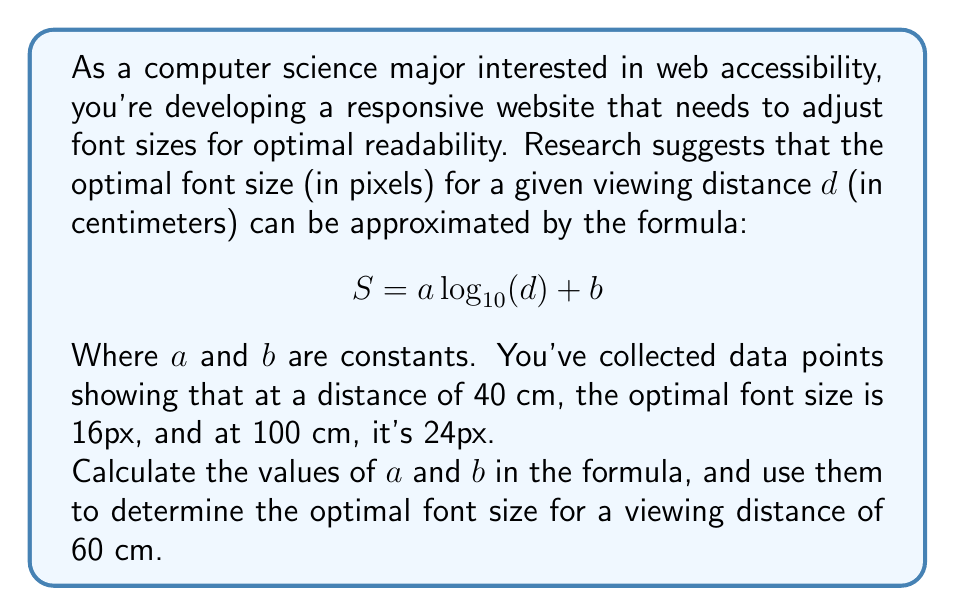Give your solution to this math problem. Let's approach this step-by-step:

1) We have two data points:
   At $d_1 = 40$ cm, $S_1 = 16$ px
   At $d_2 = 100$ cm, $S_2 = 24$ px

2) We can set up two equations using the given formula:
   $16 = a \log_{10}(40) + b$  (Equation 1)
   $24 = a \log_{10}(100) + b$ (Equation 2)

3) Simplify the logarithms:
   $16 = a \cdot 1.6021 + b$  (Equation 1)
   $24 = a \cdot 2 + b$       (Equation 2)

4) Subtract Equation 1 from Equation 2:
   $24 - 16 = a(2 - 1.6021) + (b - b)$
   $8 = 0.3979a$

5) Solve for $a$:
   $a = 8 / 0.3979 \approx 20.1055$

6) Substitute this value of $a$ into Equation 1 to solve for $b$:
   $16 = 20.1055 \cdot 1.6021 + b$
   $16 = 32.2099 + b$
   $b = 16 - 32.2099 = -16.2099$

7) Now we have our formula:
   $S = 20.1055 \log_{10}(d) - 16.2099$

8) To find the optimal font size for 60 cm:
   $S = 20.1055 \log_{10}(60) - 16.2099$
   $S = 20.1055 \cdot 1.7782 - 16.2099$
   $S = 35.7516 - 16.2099$
   $S = 19.5417$

9) Rounding to the nearest pixel:
   $S \approx 20$ px
Answer: The optimal font size for a viewing distance of 60 cm is approximately 20 pixels. 